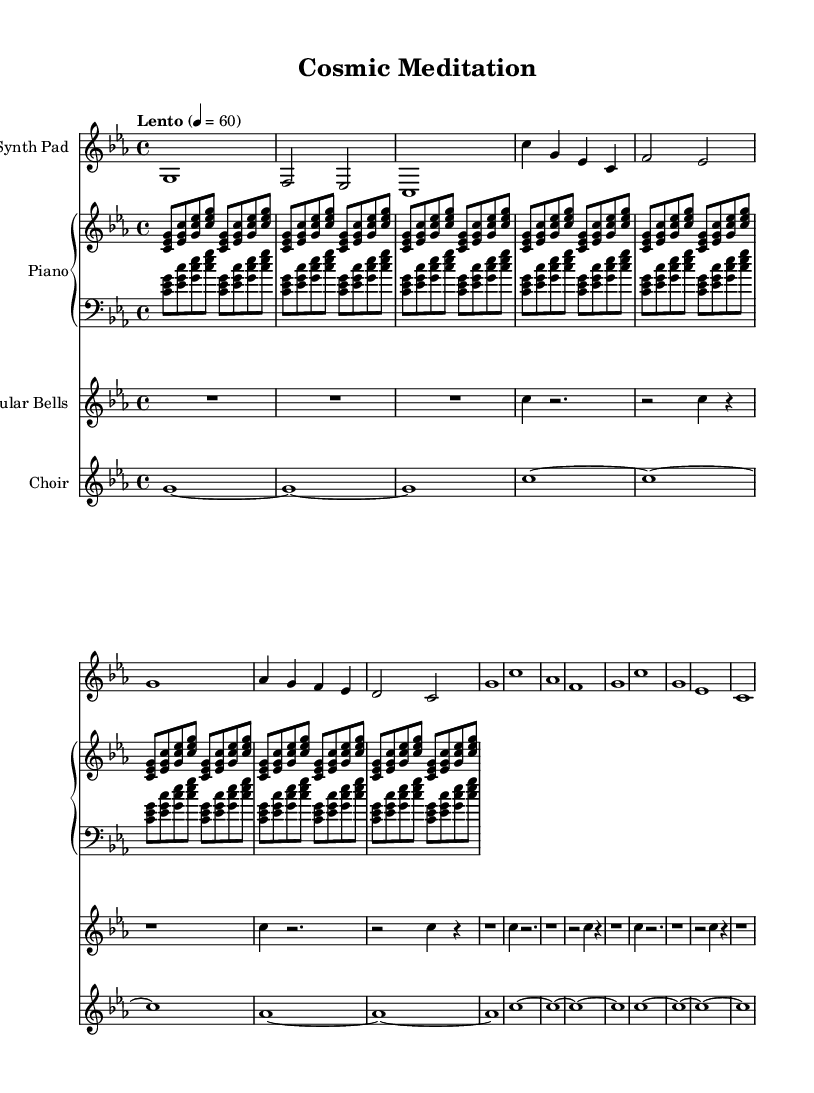What is the key signature of this music? The key signature is indicated at the beginning of the sheet music with the presence of three flat symbols, which are Bb, Eb, and Ab. Therefore, it is in C minor.
Answer: C minor What is the time signature of this music? The time signature is displayed at the beginning of the music and shows "4/4," indicating four beats per measure, with the quarter note getting one beat.
Answer: 4/4 What tempo marking is indicated in the sheet music? The tempo marking is written in Italian at the beginning of the score as "Lento," which translates to a slow tempo. The number 60 indicates beats per minute.
Answer: Lento How many voices are present in the choir section? The choir section is notated with individual notes and rests, prominently showing four separate lines throughout the score; thus, there are four distinct vocal parts or voices.
Answer: Four What is the role of the tubular bells in the composition? The tubular bells add an additional layer of texture and ethereal sound to the piece, marked by the multiple rests interspersed with notes that create a meditative quality; they are typically played softly.
Answer: Ethereal sound Which instrument has the longest note duration in the score? By examining the synth pad and piano parts, it is clear that the synth pad features sustained whole notes (c1, g1, etc.) while tubular bells have quarter notes; thus, the longest note duration appears in the synth pad.
Answer: Synth Pad 